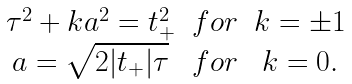Convert formula to latex. <formula><loc_0><loc_0><loc_500><loc_500>\begin{array} { c c c } \tau ^ { 2 } + k a ^ { 2 } = t _ { + } ^ { 2 } & f o r & k = \pm 1 \\ a = \sqrt { 2 | t _ { + } | \tau } & f o r & k = 0 . \end{array}</formula> 